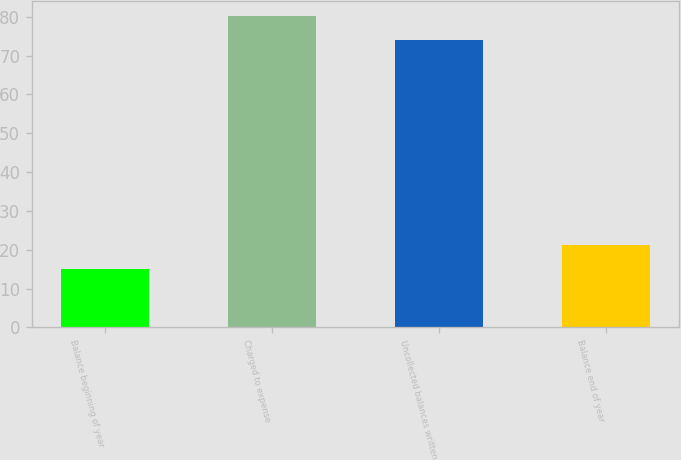Convert chart to OTSL. <chart><loc_0><loc_0><loc_500><loc_500><bar_chart><fcel>Balance beginning of year<fcel>Charged to expense<fcel>Uncollected balances written<fcel>Balance end of year<nl><fcel>15<fcel>80.1<fcel>74<fcel>21.1<nl></chart> 